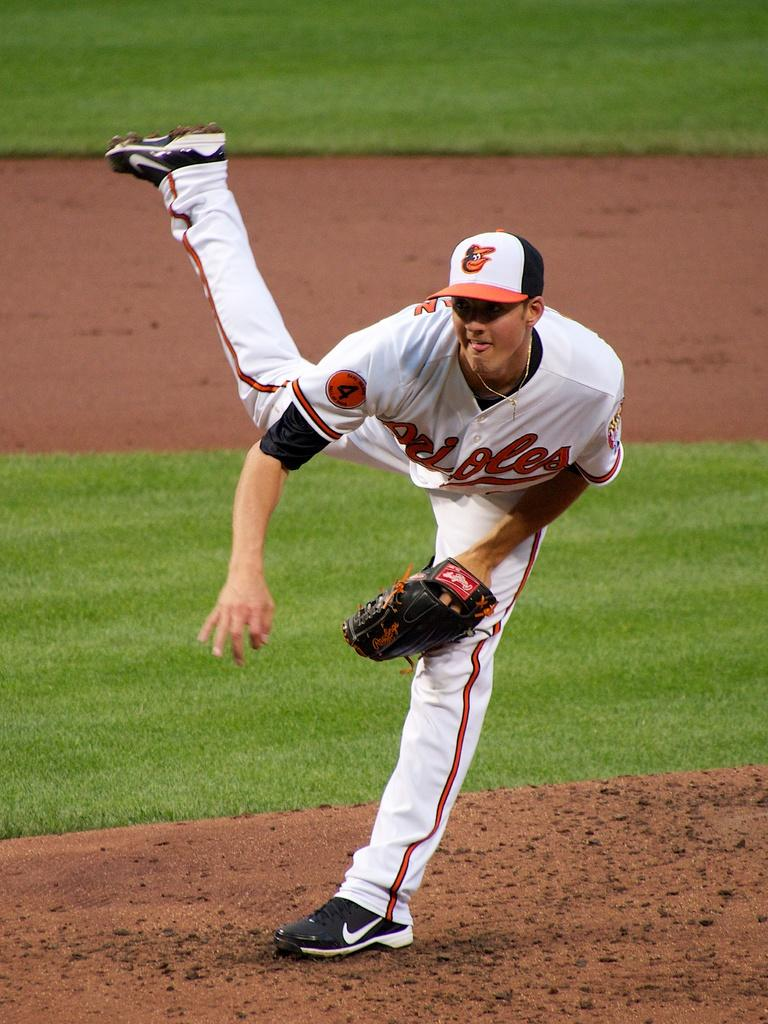<image>
Share a concise interpretation of the image provided. A pitcher for the Oriole of Baltimore in action 